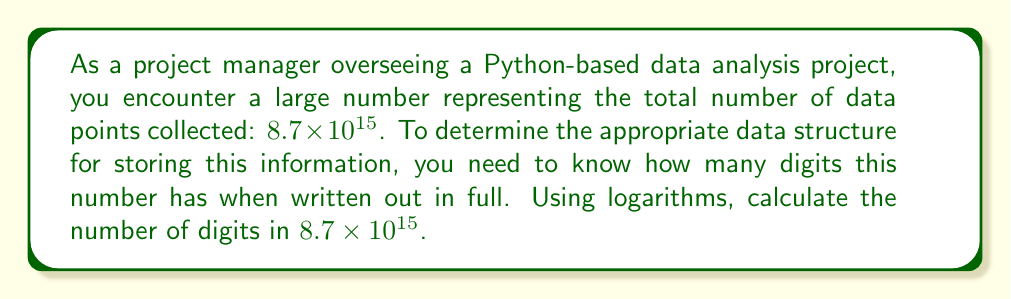Solve this math problem. To determine the number of digits in a large number using logarithms, we can follow these steps:

1. The number of digits in a positive integer $n$ is given by $\lfloor \log_{10}(n) \rfloor + 1$, where $\lfloor \cdot \rfloor$ represents the floor function.

2. In this case, we have $n = 8.7 \times 10^{15}$. Let's call the number of digits $d$.

3. Using the logarithm formula:

   $$d = \lfloor \log_{10}(8.7 \times 10^{15}) \rfloor + 1$$

4. Using the logarithm product rule:

   $$d = \lfloor \log_{10}(8.7) + \log_{10}(10^{15}) \rfloor + 1$$

5. Simplify:

   $$d = \lfloor \log_{10}(8.7) + 15 \rfloor + 1$$

6. Calculate $\log_{10}(8.7)$ (you can use a calculator for this):

   $$d = \lfloor 0.9395 + 15 \rfloor + 1$$

7. Add the values inside the floor function:

   $$d = \lfloor 15.9395 \rfloor + 1$$

8. Apply the floor function:

   $$d = 15 + 1$$

9. Calculate the final result:

   $$d = 16$$

Therefore, the number $8.7 \times 10^{15}$ has 16 digits when written out in full.
Answer: 16 digits 